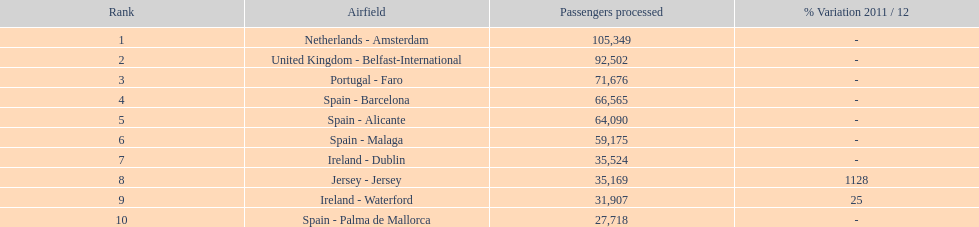Looking at the top 10 busiest routes to and from london southend airport what is the average number of passengers handled? 58,967.5. 